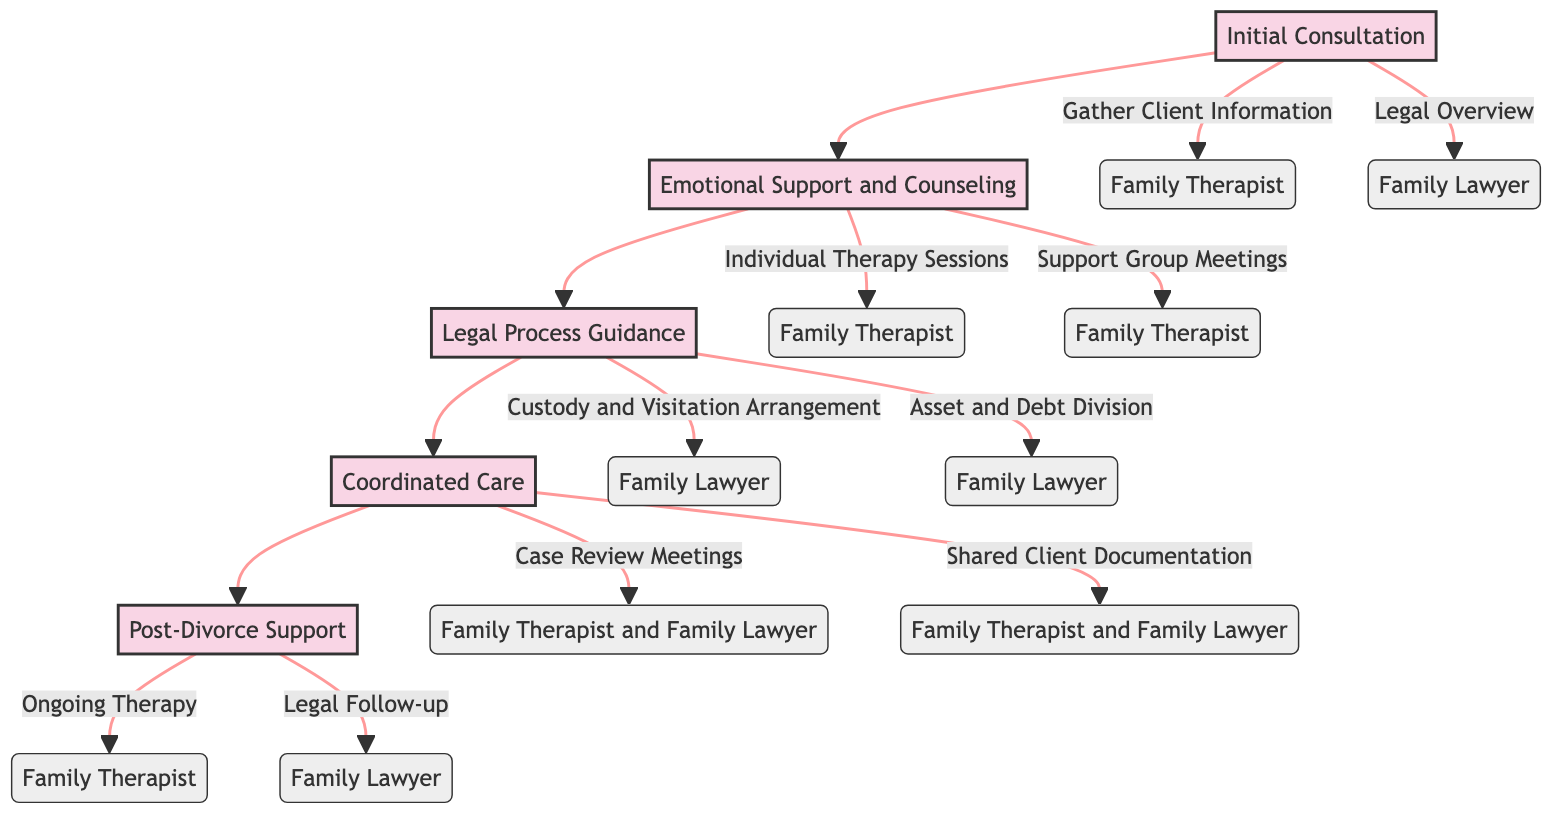What are the first two stages of the clinical pathway? The diagram clearly shows the stages starting with "Initial Consultation" and followed by "Emotional Support and Counseling". Hence, these are the first two stages.
Answer: Initial Consultation, Emotional Support and Counseling How many activities are listed under the "Legal Process Guidance" stage? By checking the "Legal Process Guidance" stage, there are two activities mentioned: "Custody and Visitation Arrangement" and "Asset and Debt Division". Thus, the number of activities is 2.
Answer: 2 Who is responsible for the "Ongoing Therapy" activity? The diagram indicates that the "Ongoing Therapy" activity is solely assigned to the "Family Therapist". Therefore, the responsible party for this activity is the Family Therapist.
Answer: Family Therapist What stage follows "Coordinated Care"? In the flow of the clinical pathway, the stage that comes after "Coordinated Care" is "Post-Divorce Support". This follows directly in the sequence of stages.
Answer: Post-Divorce Support What is the purpose of the "Case Review Meetings" activity? The diagram describes "Case Review Meetings" as regular meetings for discussing the client's progress and adjusting the support plan. This indicates the purpose is for ongoing care and adjustment of client support.
Answer: Discuss client's progress and adjust support plan What is the relationship between "Emotional Support and Counseling" and "Legal Process Guidance"? The diagram shows a direct flow from "Emotional Support and Counseling" to "Legal Process Guidance", indicating that after providing emotional support, the next step is to guide the client through the legal process.
Answer: Direct flow/relationship What are the responsible parties for "Shared Client Documentation"? According to the diagram, the responsible parties for "Shared Client Documentation" activity are both the Family Therapist and the Family Lawyer, as indicated in the description of the coordinated care stage.
Answer: Family Therapist and Family Lawyer How many stages does this clinical pathway contain? By counting each stage represented in the diagram, we see five stages: Initial Consultation, Emotional Support and Counseling, Legal Process Guidance, Coordinated Care, and Post-Divorce Support. Hence, the number is 5.
Answer: 5 What is the final activity in this clinical pathway? The diagram indicates that the last stage is "Post-Divorce Support", and within this stage, the final activity listed is "Legal Follow-up". Thus, this is the last activity in the pathway.
Answer: Legal Follow-up 